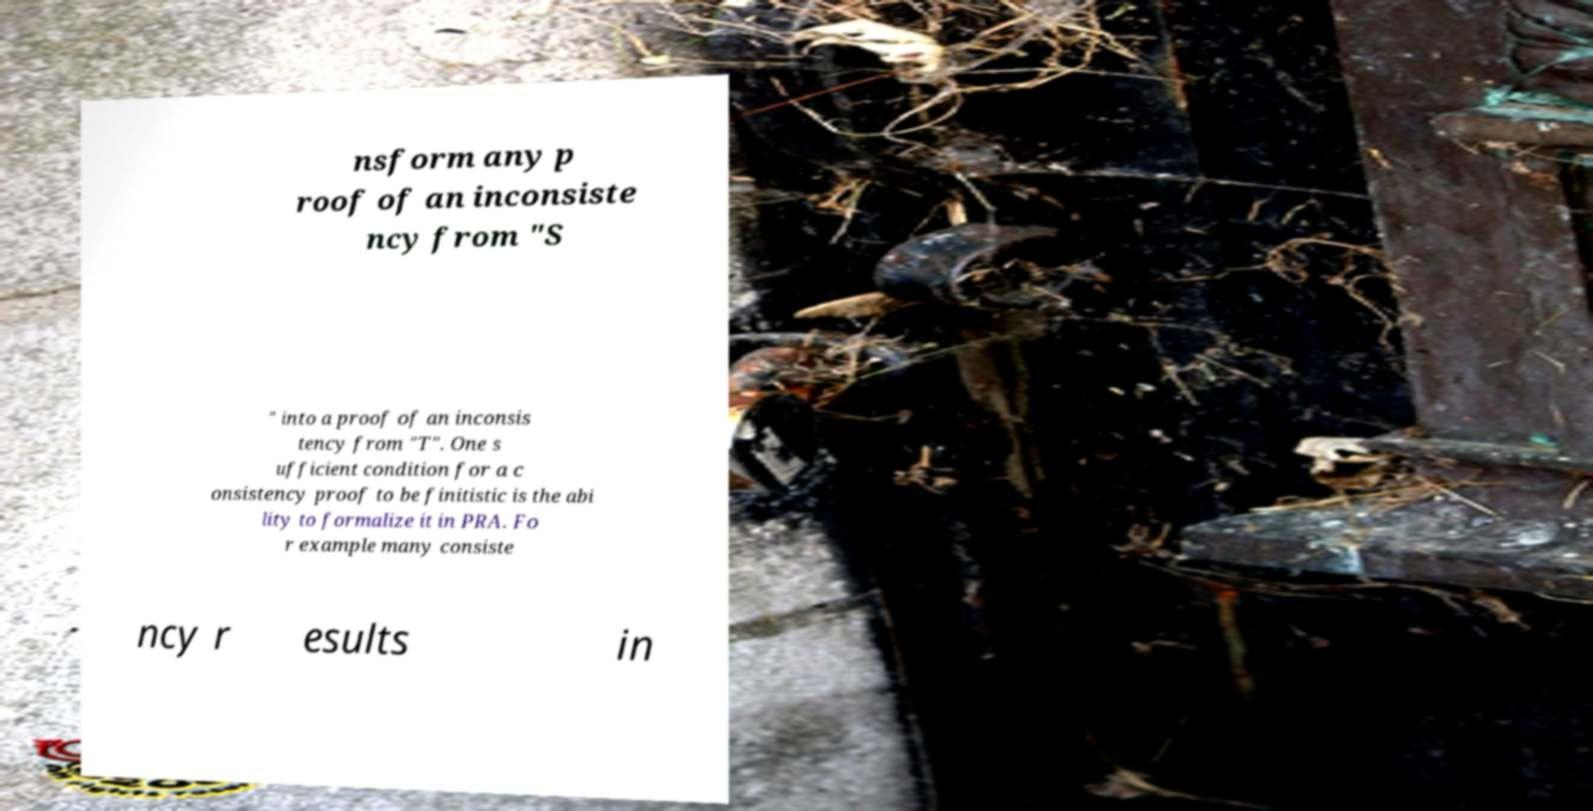There's text embedded in this image that I need extracted. Can you transcribe it verbatim? nsform any p roof of an inconsiste ncy from "S " into a proof of an inconsis tency from "T". One s ufficient condition for a c onsistency proof to be finitistic is the abi lity to formalize it in PRA. Fo r example many consiste ncy r esults in 